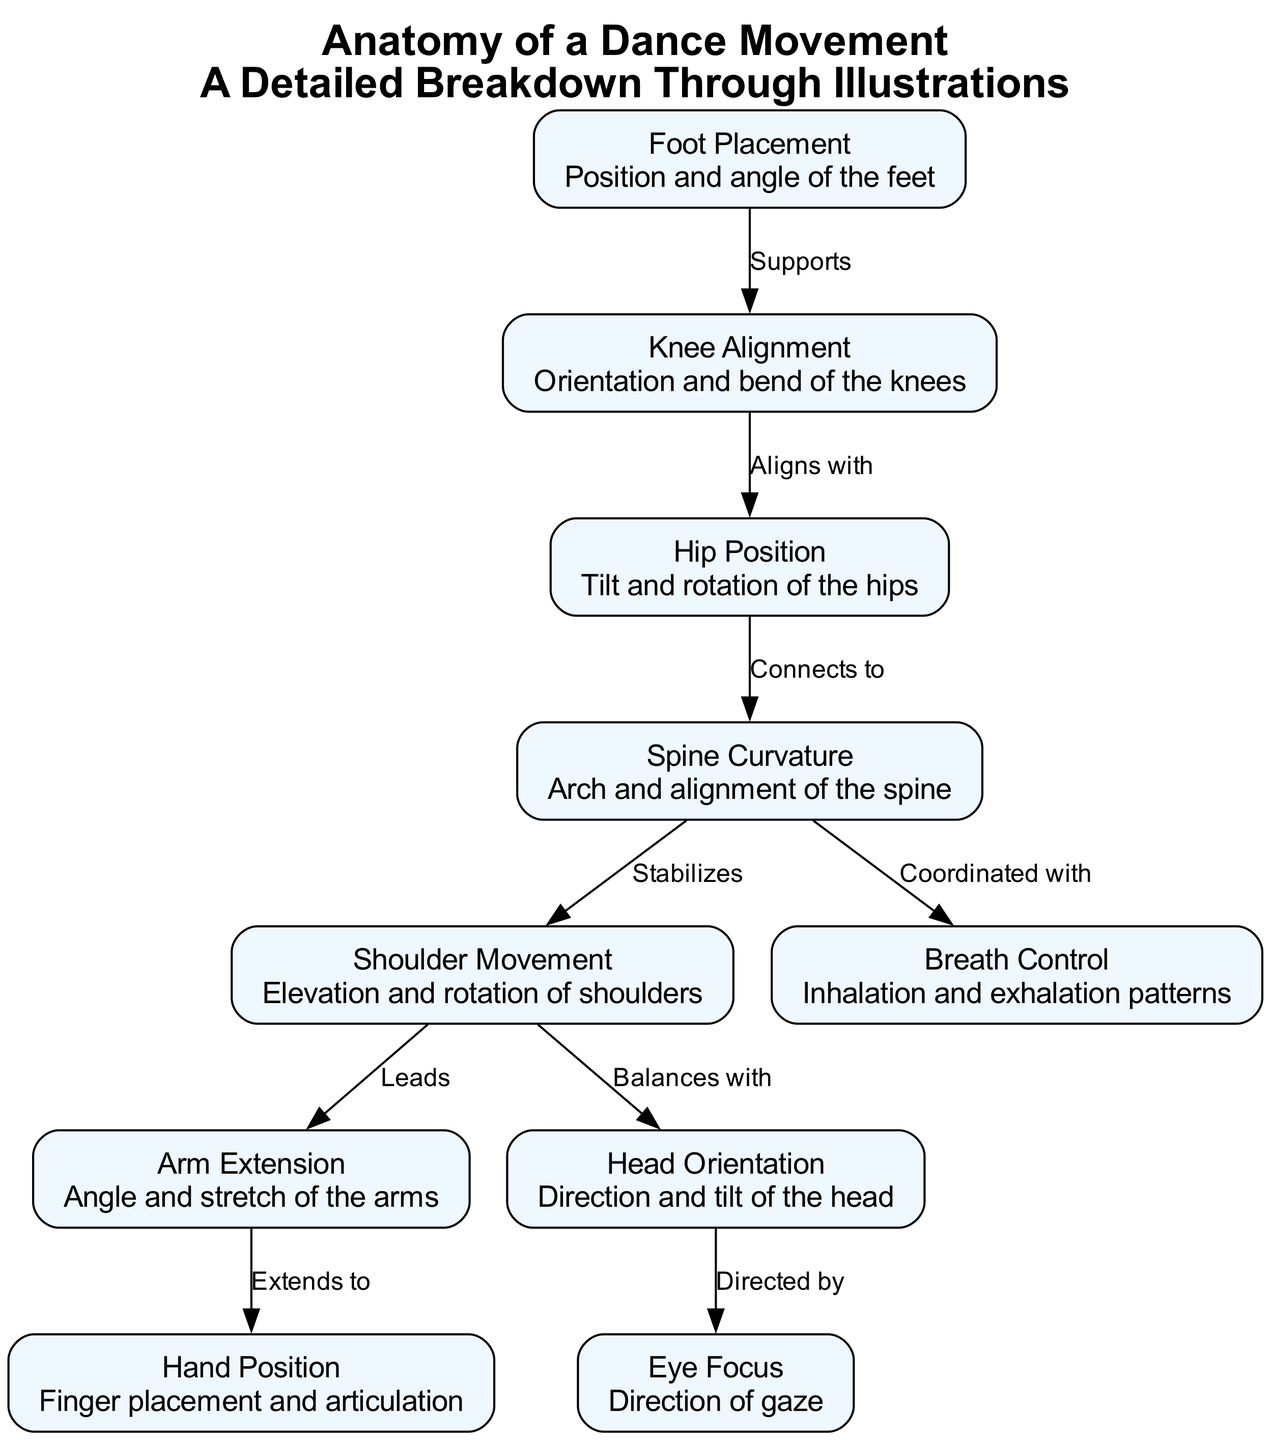What is the total number of nodes in the diagram? The diagram includes 10 distinct nodes that represent different elements of the dance movement anatomy. Each node corresponds to a specific physical aspect or position involved in dance.
Answer: 10 Which node connects to the "Spine Curvature"? The "Hip Position" node connects to the "Spine Curvature" as indicated by the edge labeled "Connects to." This shows a direct relationship in the anatomical movement breakdown.
Answer: Hip Position What does "Shoulder Movement" lead to? The "Shoulder Movement" node leads to the "Arm Extension" node, as shown by the edge labeled "Leads." This indicates a sequential anatomical function where shoulder movement influences arm extension.
Answer: Arm Extension Which two nodes share a relationship described as "Balances with"? The "Shoulder Movement" and "Head Orientation" nodes are linked by the relationship "Balances with," indicating that the positioning of the shoulders is balanced by the head's orientation while dancing.
Answer: Head Orientation How many relationships are present in the diagram? There are 9 relationships (edges) connecting the 10 nodes, each representing how different dance movement elements interact with one another in terms of support, alignment, stabilization, and direction.
Answer: 9 Which node is oriented by the "Head Orientation"? The node "Eye Focus" is directed by the "Head Orientation." This indicates that where the dancer's head is facing influences the direction of their gaze.
Answer: Eye Focus What anatomical aspect does "Breath Control" coordinate with? The "Breath Control" node is coordinated with the "Spine Curvature." This relationship implies that the dancer's breathing patterns are aligned with the positioning and movement of the spine.
Answer: Spine Curvature Which node describes the position and angle of the feet? The "Foot Placement" node describes the position and angle of the feet within the context of dance movement. This information is crucial for understanding overall balance and posture.
Answer: Foot Placement How does "Knee Alignment" relate to "Hip Position"? "Knee Alignment" aligns with "Hip Position," which indicates that the orientation and bend of the knees are directly related to the placement and tilt of the hips within a dance routine.
Answer: Aligns with What does the edge labeled "Supports" indicate in relation to nodes? The "Supports" edge indicates that the "Foot Placement" directly supports the "Knee Alignment," suggesting that proper foot positioning is foundational for correct knee orientation.
Answer: Supports 